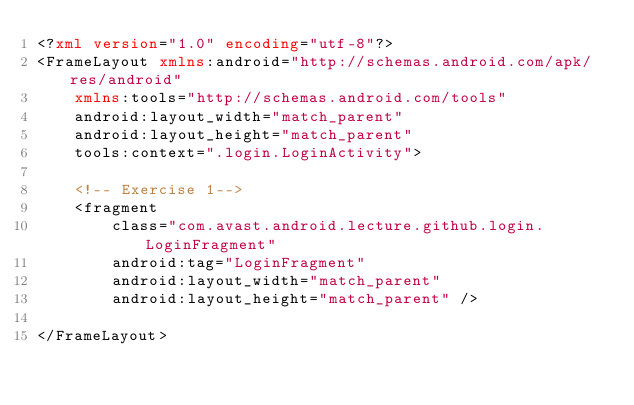<code> <loc_0><loc_0><loc_500><loc_500><_XML_><?xml version="1.0" encoding="utf-8"?>
<FrameLayout xmlns:android="http://schemas.android.com/apk/res/android"
    xmlns:tools="http://schemas.android.com/tools"
    android:layout_width="match_parent"
    android:layout_height="match_parent"
    tools:context=".login.LoginActivity">

    <!-- Exercise 1-->
    <fragment
        class="com.avast.android.lecture.github.login.LoginFragment"
        android:tag="LoginFragment"
        android:layout_width="match_parent"
        android:layout_height="match_parent" />

</FrameLayout>
</code> 